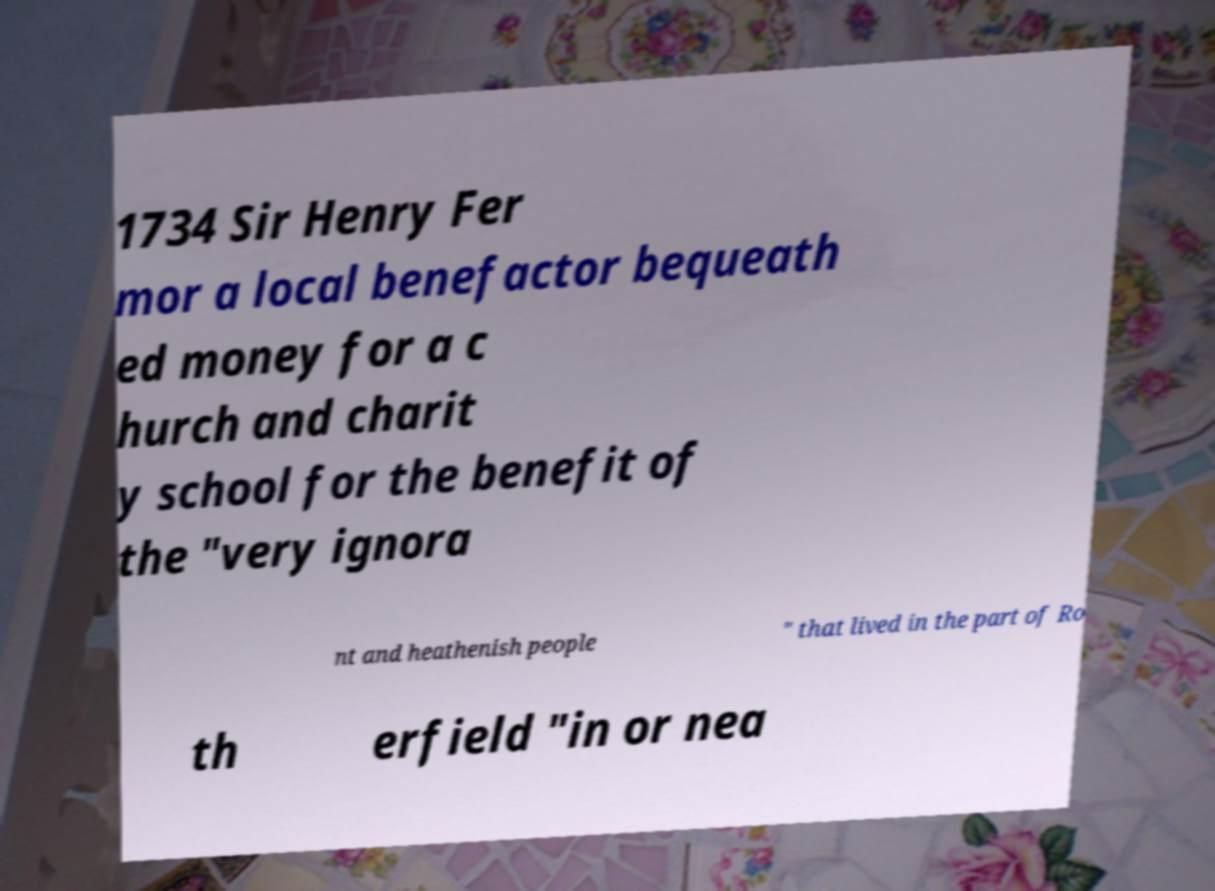There's text embedded in this image that I need extracted. Can you transcribe it verbatim? 1734 Sir Henry Fer mor a local benefactor bequeath ed money for a c hurch and charit y school for the benefit of the "very ignora nt and heathenish people " that lived in the part of Ro th erfield "in or nea 